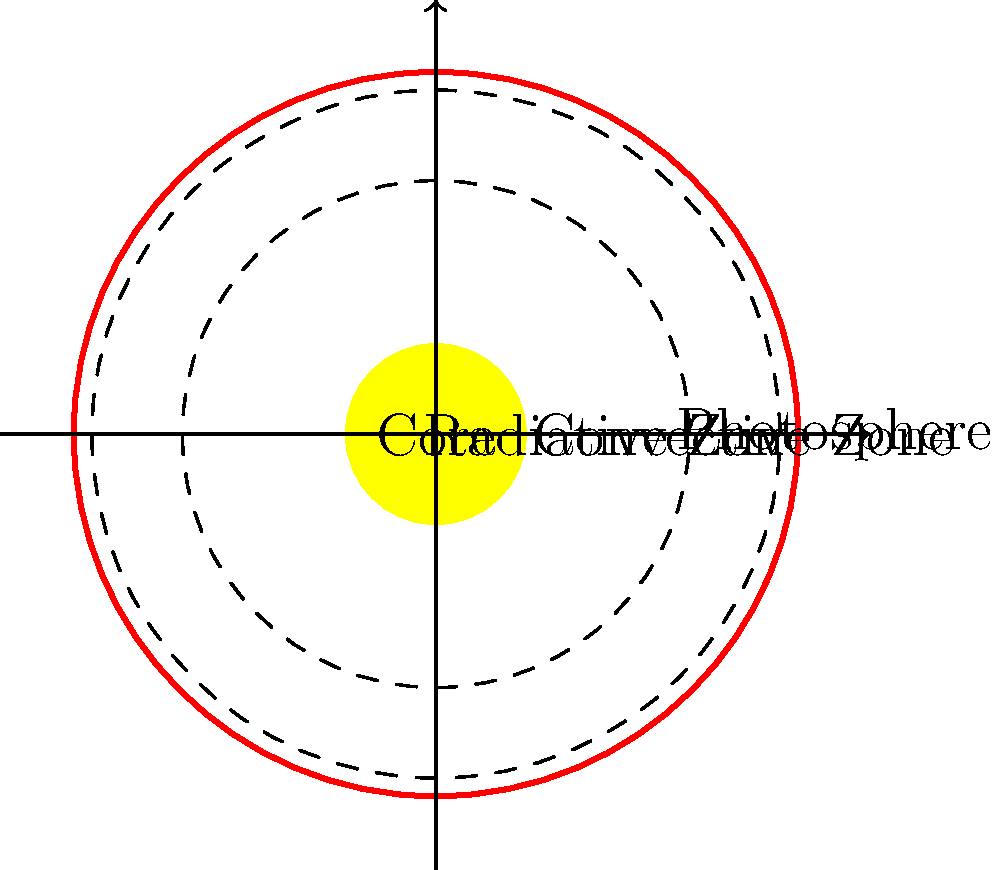En el diagrama de la estructura del Sol, ¿qué zona se encuentra entre el núcleo y la zona convectiva? Para responder a esta pregunta, debemos analizar la estructura del Sol paso a paso:

1. El diagrama muestra un corte transversal del Sol.
2. En el centro, vemos una región etiquetada como "Core" (Núcleo).
3. Alrededor del núcleo, hay una región delimitada por una línea punteada.
4. Esta región está etiquetada como "Radiative Zone" (Zona Radiativa).
5. Más allá de la zona radiativa, hay otra región delimitada por una línea punteada etiquetada como "Convective Zone" (Zona Convectiva).
6. La capa más externa se etiqueta como "Photosphere" (Fotosfera).

Observando la disposición de estas capas, podemos ver que la zona que se encuentra entre el núcleo y la zona convectiva es la zona radiativa.
Answer: Zona radiativa 